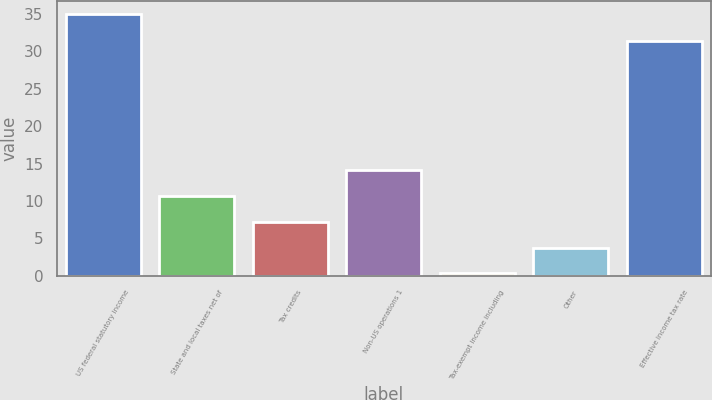<chart> <loc_0><loc_0><loc_500><loc_500><bar_chart><fcel>US federal statutory income<fcel>State and local taxes net of<fcel>Tax credits<fcel>Non-US operations 1<fcel>Tax-exempt income including<fcel>Other<fcel>Effective income tax rate<nl><fcel>35<fcel>10.71<fcel>7.24<fcel>14.18<fcel>0.3<fcel>3.77<fcel>31.4<nl></chart> 